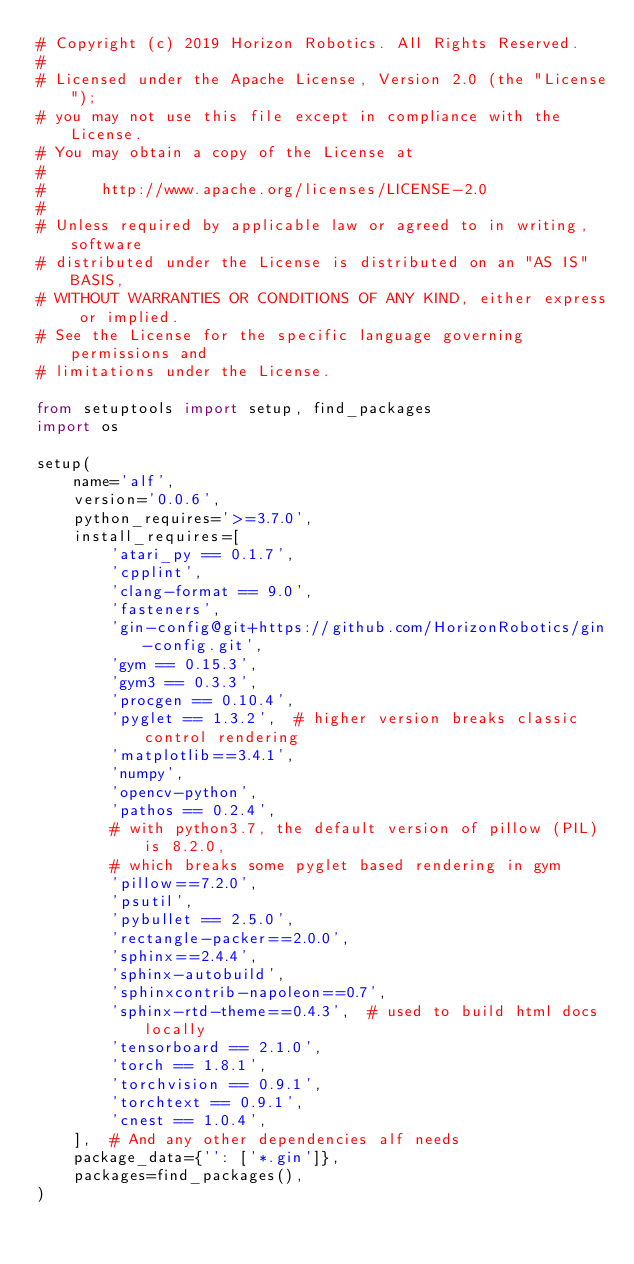<code> <loc_0><loc_0><loc_500><loc_500><_Python_># Copyright (c) 2019 Horizon Robotics. All Rights Reserved.
#
# Licensed under the Apache License, Version 2.0 (the "License");
# you may not use this file except in compliance with the License.
# You may obtain a copy of the License at
#
#      http://www.apache.org/licenses/LICENSE-2.0
#
# Unless required by applicable law or agreed to in writing, software
# distributed under the License is distributed on an "AS IS" BASIS,
# WITHOUT WARRANTIES OR CONDITIONS OF ANY KIND, either express or implied.
# See the License for the specific language governing permissions and
# limitations under the License.

from setuptools import setup, find_packages
import os

setup(
    name='alf',
    version='0.0.6',
    python_requires='>=3.7.0',
    install_requires=[
        'atari_py == 0.1.7',
        'cpplint',
        'clang-format == 9.0',
        'fasteners',
        'gin-config@git+https://github.com/HorizonRobotics/gin-config.git',
        'gym == 0.15.3',
        'gym3 == 0.3.3',
        'procgen == 0.10.4',
        'pyglet == 1.3.2',  # higher version breaks classic control rendering
        'matplotlib==3.4.1',
        'numpy',
        'opencv-python',
        'pathos == 0.2.4',
        # with python3.7, the default version of pillow (PIL) is 8.2.0,
        # which breaks some pyglet based rendering in gym
        'pillow==7.2.0',
        'psutil',
        'pybullet == 2.5.0',
        'rectangle-packer==2.0.0',
        'sphinx==2.4.4',
        'sphinx-autobuild',
        'sphinxcontrib-napoleon==0.7',
        'sphinx-rtd-theme==0.4.3',  # used to build html docs locally
        'tensorboard == 2.1.0',
        'torch == 1.8.1',
        'torchvision == 0.9.1',
        'torchtext == 0.9.1',
        'cnest == 1.0.4',
    ],  # And any other dependencies alf needs
    package_data={'': ['*.gin']},
    packages=find_packages(),
)
</code> 